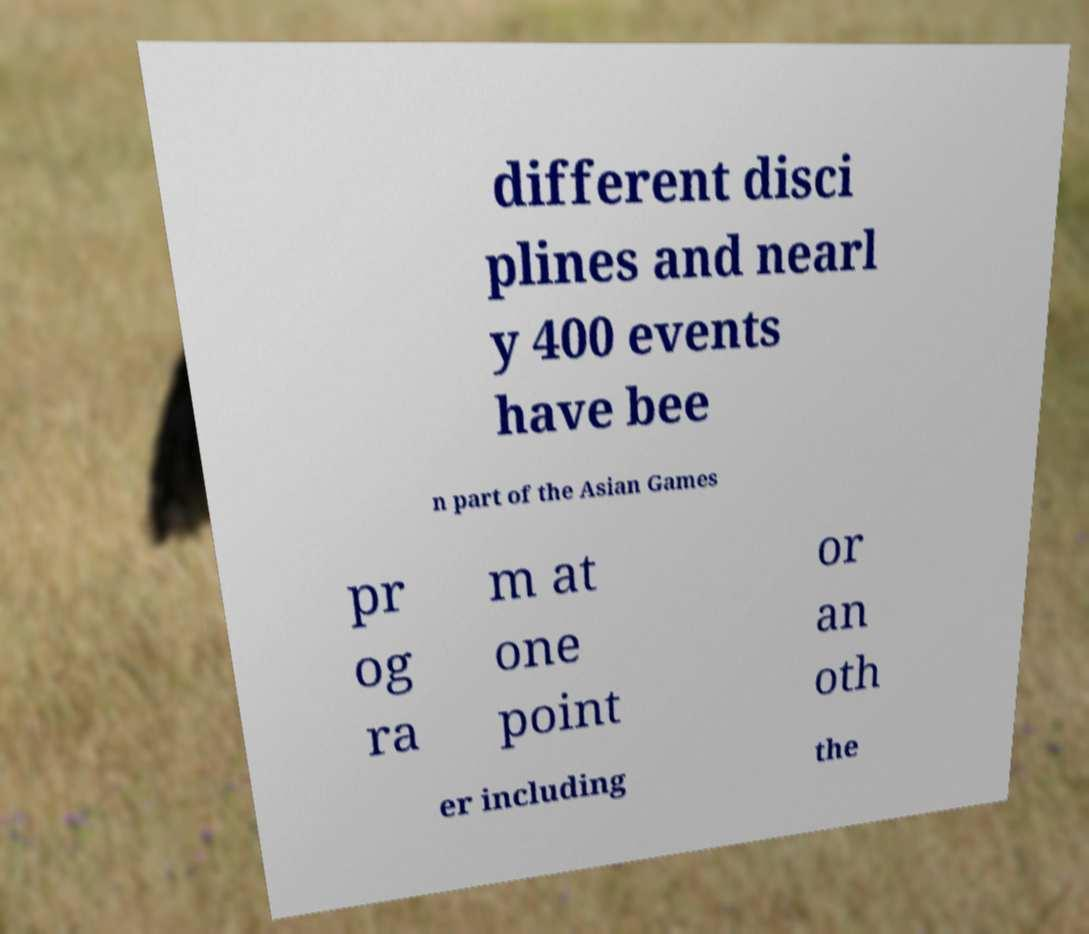Could you assist in decoding the text presented in this image and type it out clearly? different disci plines and nearl y 400 events have bee n part of the Asian Games pr og ra m at one point or an oth er including the 